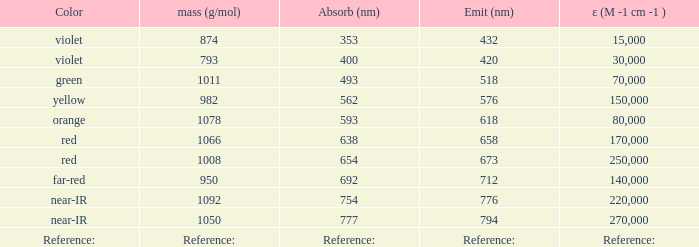For an absorption of 593 nm, what is the emission wavelength (in nanometers)? 618.0. 